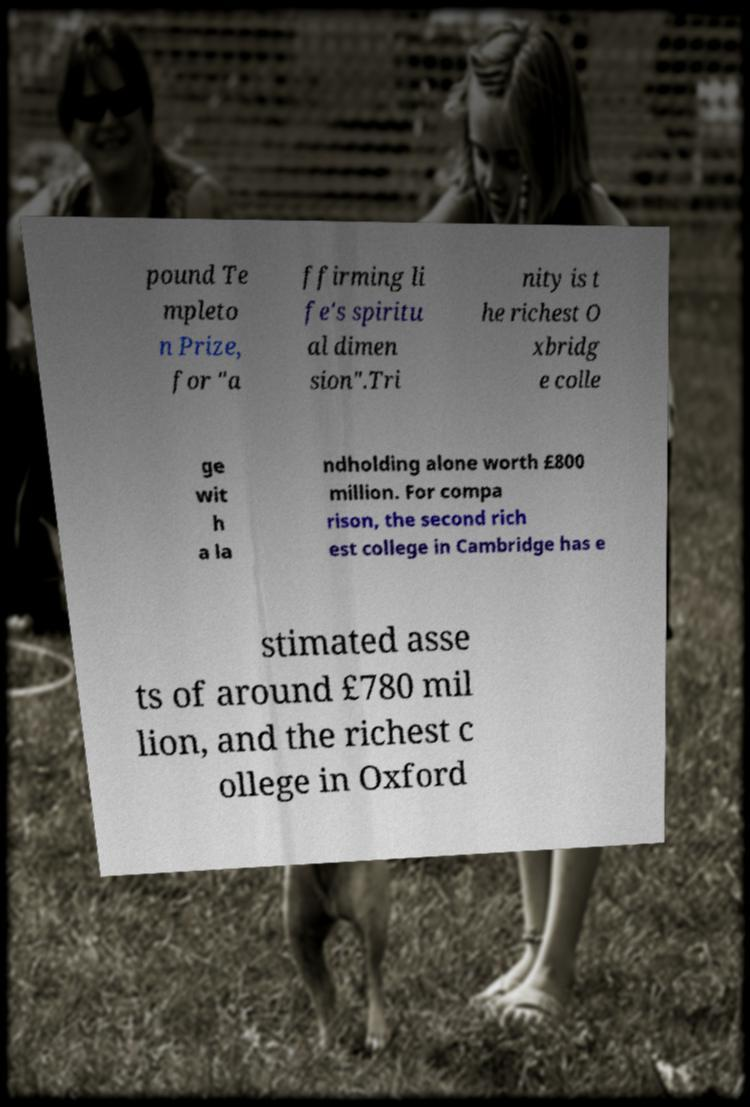Can you read and provide the text displayed in the image?This photo seems to have some interesting text. Can you extract and type it out for me? pound Te mpleto n Prize, for "a ffirming li fe's spiritu al dimen sion".Tri nity is t he richest O xbridg e colle ge wit h a la ndholding alone worth £800 million. For compa rison, the second rich est college in Cambridge has e stimated asse ts of around £780 mil lion, and the richest c ollege in Oxford 